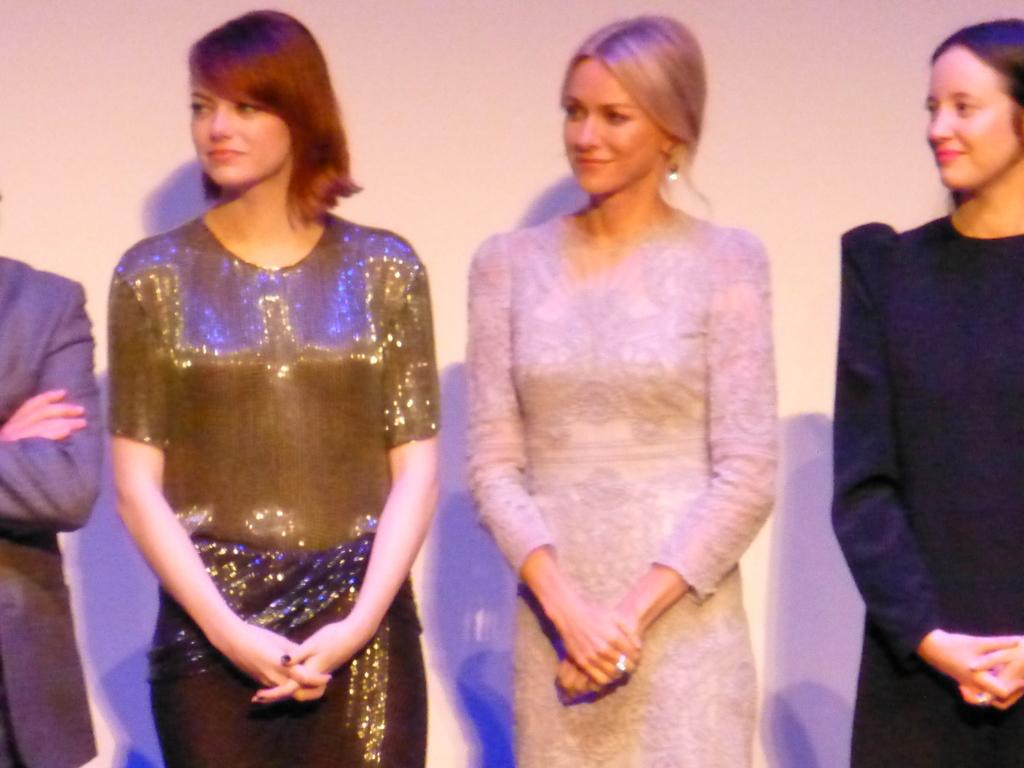How many people are in the image? There are four people in the image. Can you describe the individuals in the image? There are three women and one person in the image. Where are the people located in the image? The three women and the person are standing on a wall. What is visible in the background of the image? There is a wall visible in the background of the image. How many cows are standing on the wall with the people in the image? There are no cows present in the image; it features three women and one person standing on a wall. What is the relationship between the person and the three women in the image? The provided facts do not specify the relationship between the person and the three women, so we cannot determine their connection. 